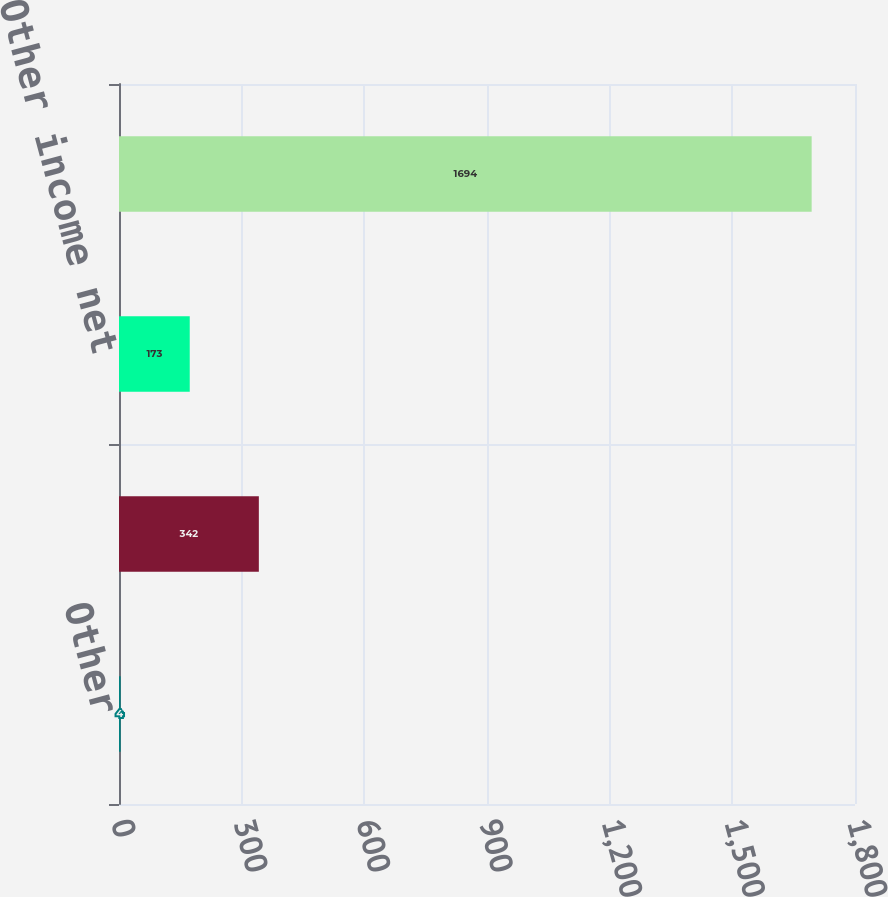Convert chart to OTSL. <chart><loc_0><loc_0><loc_500><loc_500><bar_chart><fcel>Other<fcel>Other expense<fcel>Other income net<fcel>Pre-tax income (loss) before<nl><fcel>4<fcel>342<fcel>173<fcel>1694<nl></chart> 